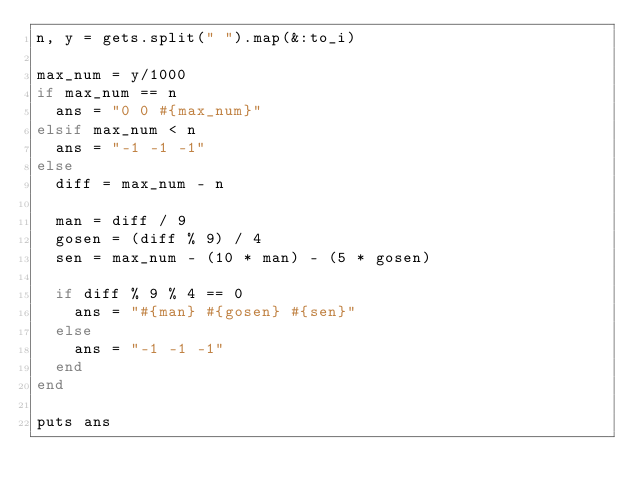Convert code to text. <code><loc_0><loc_0><loc_500><loc_500><_Ruby_>n, y = gets.split(" ").map(&:to_i)

max_num = y/1000
if max_num == n
  ans = "0 0 #{max_num}"
elsif max_num < n
  ans = "-1 -1 -1"
else
  diff = max_num - n

  man = diff / 9
  gosen = (diff % 9) / 4
  sen = max_num - (10 * man) - (5 * gosen)

  if diff % 9 % 4 == 0
    ans = "#{man} #{gosen} #{sen}"
  else
    ans = "-1 -1 -1"
  end
end

puts ans</code> 